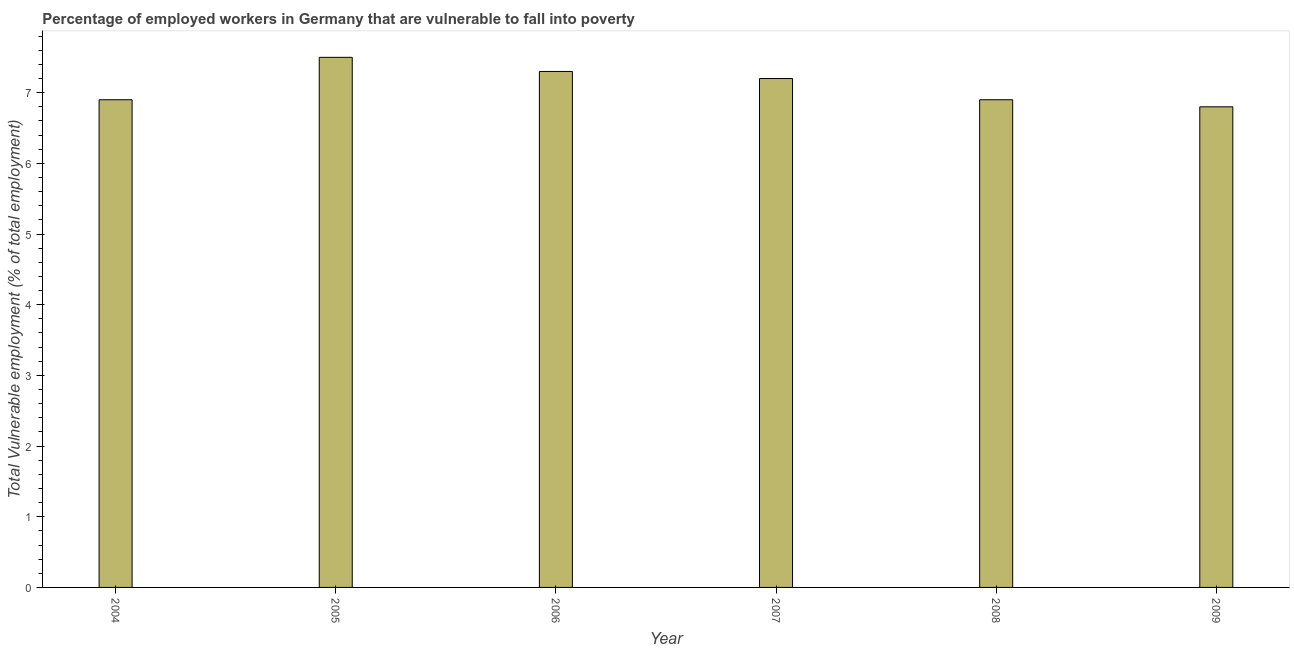Does the graph contain any zero values?
Offer a terse response. No. What is the title of the graph?
Provide a succinct answer. Percentage of employed workers in Germany that are vulnerable to fall into poverty. What is the label or title of the X-axis?
Give a very brief answer. Year. What is the label or title of the Y-axis?
Your response must be concise. Total Vulnerable employment (% of total employment). What is the total vulnerable employment in 2008?
Provide a succinct answer. 6.9. Across all years, what is the minimum total vulnerable employment?
Your response must be concise. 6.8. What is the sum of the total vulnerable employment?
Ensure brevity in your answer.  42.6. What is the difference between the total vulnerable employment in 2008 and 2009?
Keep it short and to the point. 0.1. What is the average total vulnerable employment per year?
Provide a short and direct response. 7.1. What is the median total vulnerable employment?
Give a very brief answer. 7.05. In how many years, is the total vulnerable employment greater than 2 %?
Offer a very short reply. 6. What is the ratio of the total vulnerable employment in 2007 to that in 2009?
Your answer should be very brief. 1.06. Is the difference between the total vulnerable employment in 2006 and 2007 greater than the difference between any two years?
Your response must be concise. No. Is the sum of the total vulnerable employment in 2004 and 2005 greater than the maximum total vulnerable employment across all years?
Provide a succinct answer. Yes. What is the difference between the highest and the lowest total vulnerable employment?
Your answer should be very brief. 0.7. How many bars are there?
Provide a short and direct response. 6. Are all the bars in the graph horizontal?
Your response must be concise. No. How many years are there in the graph?
Provide a short and direct response. 6. What is the difference between two consecutive major ticks on the Y-axis?
Offer a very short reply. 1. What is the Total Vulnerable employment (% of total employment) in 2004?
Your response must be concise. 6.9. What is the Total Vulnerable employment (% of total employment) of 2005?
Keep it short and to the point. 7.5. What is the Total Vulnerable employment (% of total employment) of 2006?
Make the answer very short. 7.3. What is the Total Vulnerable employment (% of total employment) in 2007?
Your answer should be very brief. 7.2. What is the Total Vulnerable employment (% of total employment) of 2008?
Your answer should be compact. 6.9. What is the Total Vulnerable employment (% of total employment) in 2009?
Provide a succinct answer. 6.8. What is the difference between the Total Vulnerable employment (% of total employment) in 2004 and 2005?
Offer a very short reply. -0.6. What is the difference between the Total Vulnerable employment (% of total employment) in 2004 and 2006?
Offer a terse response. -0.4. What is the difference between the Total Vulnerable employment (% of total employment) in 2004 and 2007?
Make the answer very short. -0.3. What is the difference between the Total Vulnerable employment (% of total employment) in 2005 and 2006?
Your answer should be compact. 0.2. What is the difference between the Total Vulnerable employment (% of total employment) in 2005 and 2008?
Give a very brief answer. 0.6. What is the difference between the Total Vulnerable employment (% of total employment) in 2005 and 2009?
Ensure brevity in your answer.  0.7. What is the difference between the Total Vulnerable employment (% of total employment) in 2006 and 2007?
Give a very brief answer. 0.1. What is the difference between the Total Vulnerable employment (% of total employment) in 2006 and 2009?
Make the answer very short. 0.5. What is the difference between the Total Vulnerable employment (% of total employment) in 2007 and 2008?
Provide a short and direct response. 0.3. What is the difference between the Total Vulnerable employment (% of total employment) in 2008 and 2009?
Your answer should be compact. 0.1. What is the ratio of the Total Vulnerable employment (% of total employment) in 2004 to that in 2005?
Offer a very short reply. 0.92. What is the ratio of the Total Vulnerable employment (% of total employment) in 2004 to that in 2006?
Give a very brief answer. 0.94. What is the ratio of the Total Vulnerable employment (% of total employment) in 2004 to that in 2007?
Your answer should be compact. 0.96. What is the ratio of the Total Vulnerable employment (% of total employment) in 2005 to that in 2007?
Give a very brief answer. 1.04. What is the ratio of the Total Vulnerable employment (% of total employment) in 2005 to that in 2008?
Provide a short and direct response. 1.09. What is the ratio of the Total Vulnerable employment (% of total employment) in 2005 to that in 2009?
Make the answer very short. 1.1. What is the ratio of the Total Vulnerable employment (% of total employment) in 2006 to that in 2007?
Make the answer very short. 1.01. What is the ratio of the Total Vulnerable employment (% of total employment) in 2006 to that in 2008?
Give a very brief answer. 1.06. What is the ratio of the Total Vulnerable employment (% of total employment) in 2006 to that in 2009?
Provide a short and direct response. 1.07. What is the ratio of the Total Vulnerable employment (% of total employment) in 2007 to that in 2008?
Keep it short and to the point. 1.04. What is the ratio of the Total Vulnerable employment (% of total employment) in 2007 to that in 2009?
Give a very brief answer. 1.06. 